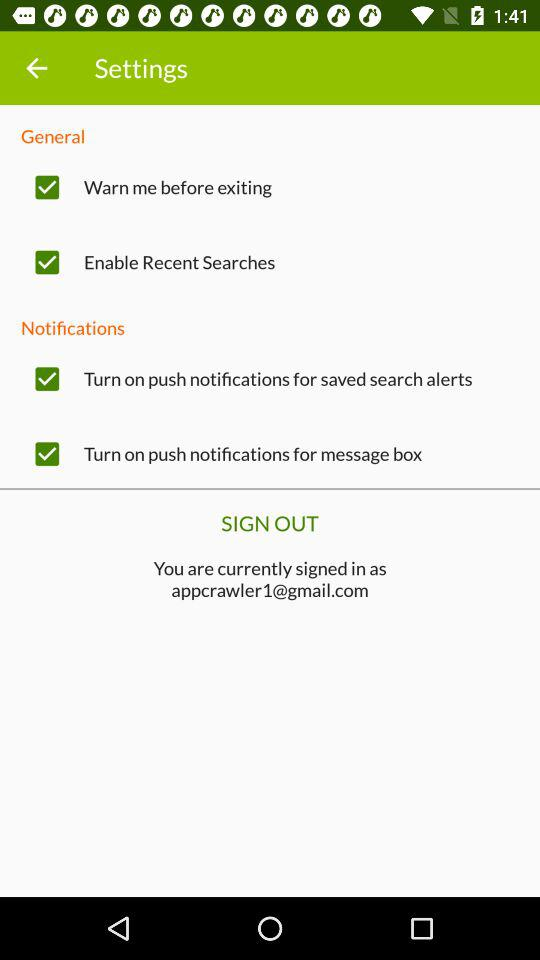What is the email address? The email address is appcrawler1@gmail.com. 